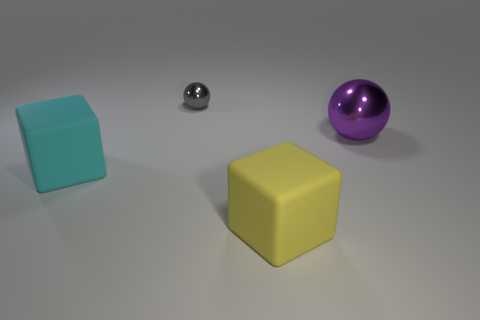Add 2 big cyan objects. How many objects exist? 6 Add 4 brown metal cylinders. How many brown metal cylinders exist? 4 Subtract 0 brown blocks. How many objects are left? 4 Subtract all big cyan matte balls. Subtract all small metallic spheres. How many objects are left? 3 Add 4 yellow rubber objects. How many yellow rubber objects are left? 5 